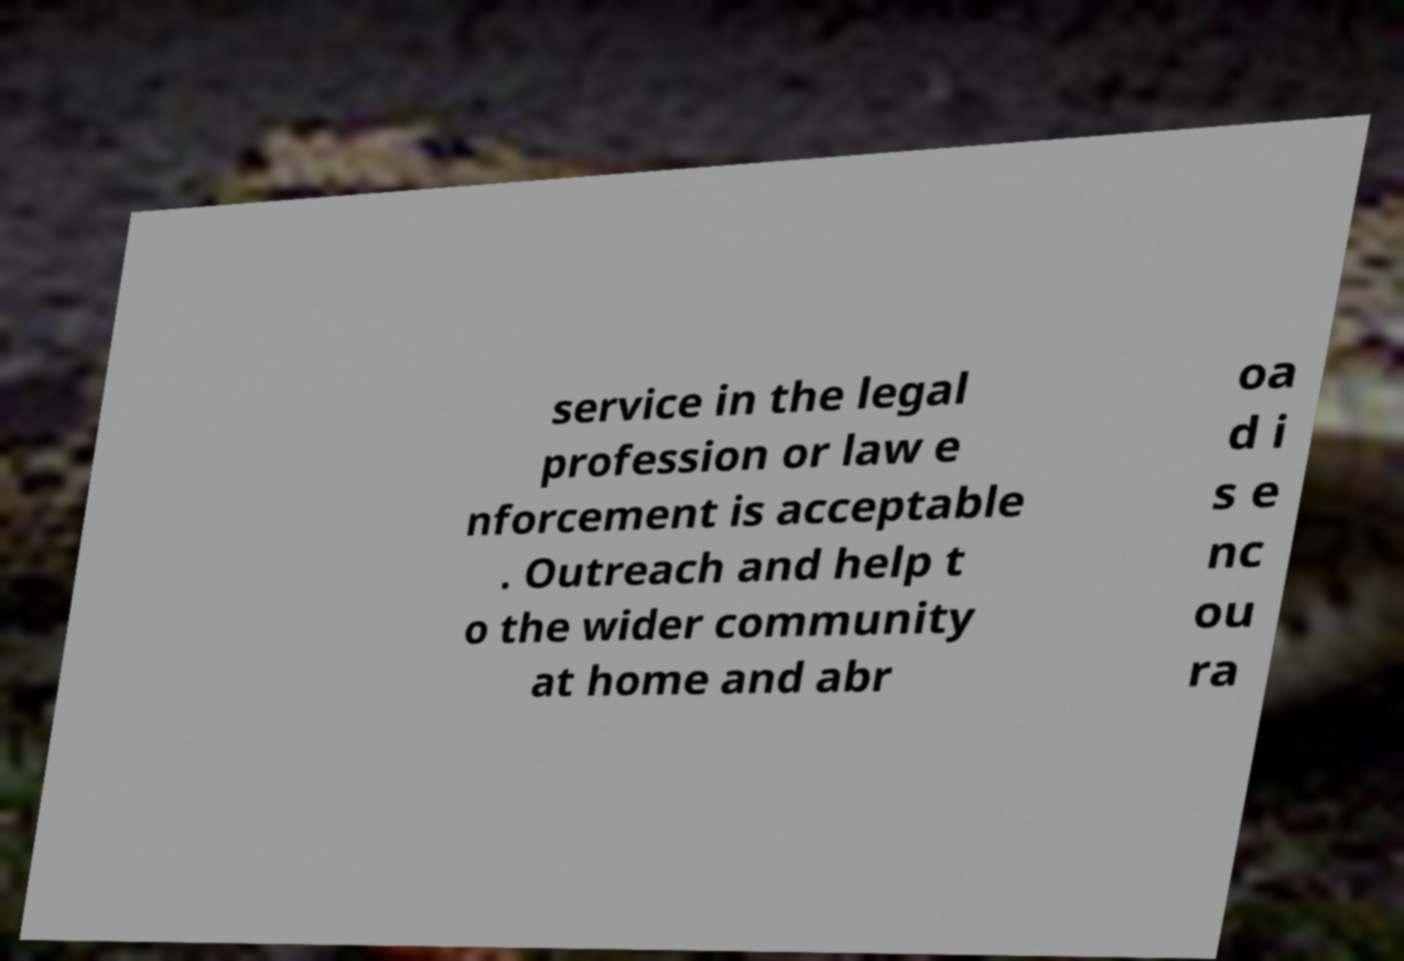There's text embedded in this image that I need extracted. Can you transcribe it verbatim? service in the legal profession or law e nforcement is acceptable . Outreach and help t o the wider community at home and abr oa d i s e nc ou ra 